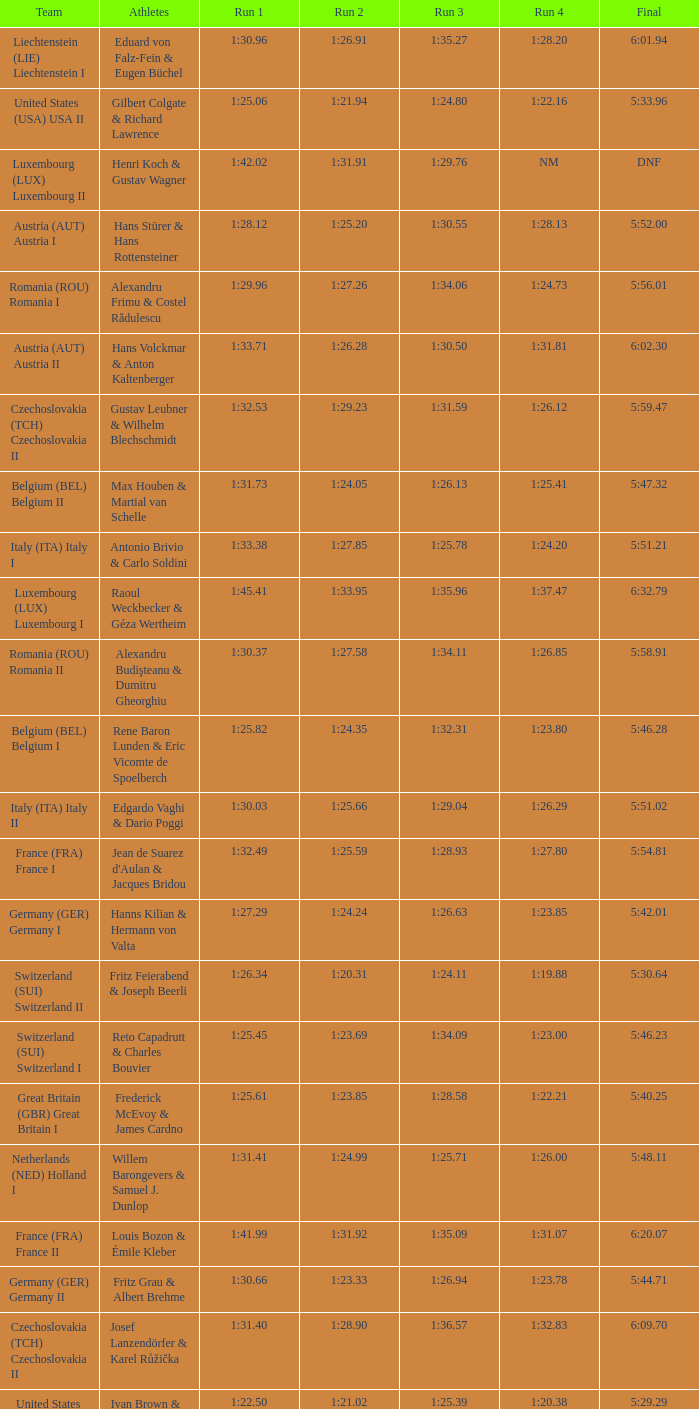Which Run 4 has a Run 1 of 1:25.82? 1:23.80. 